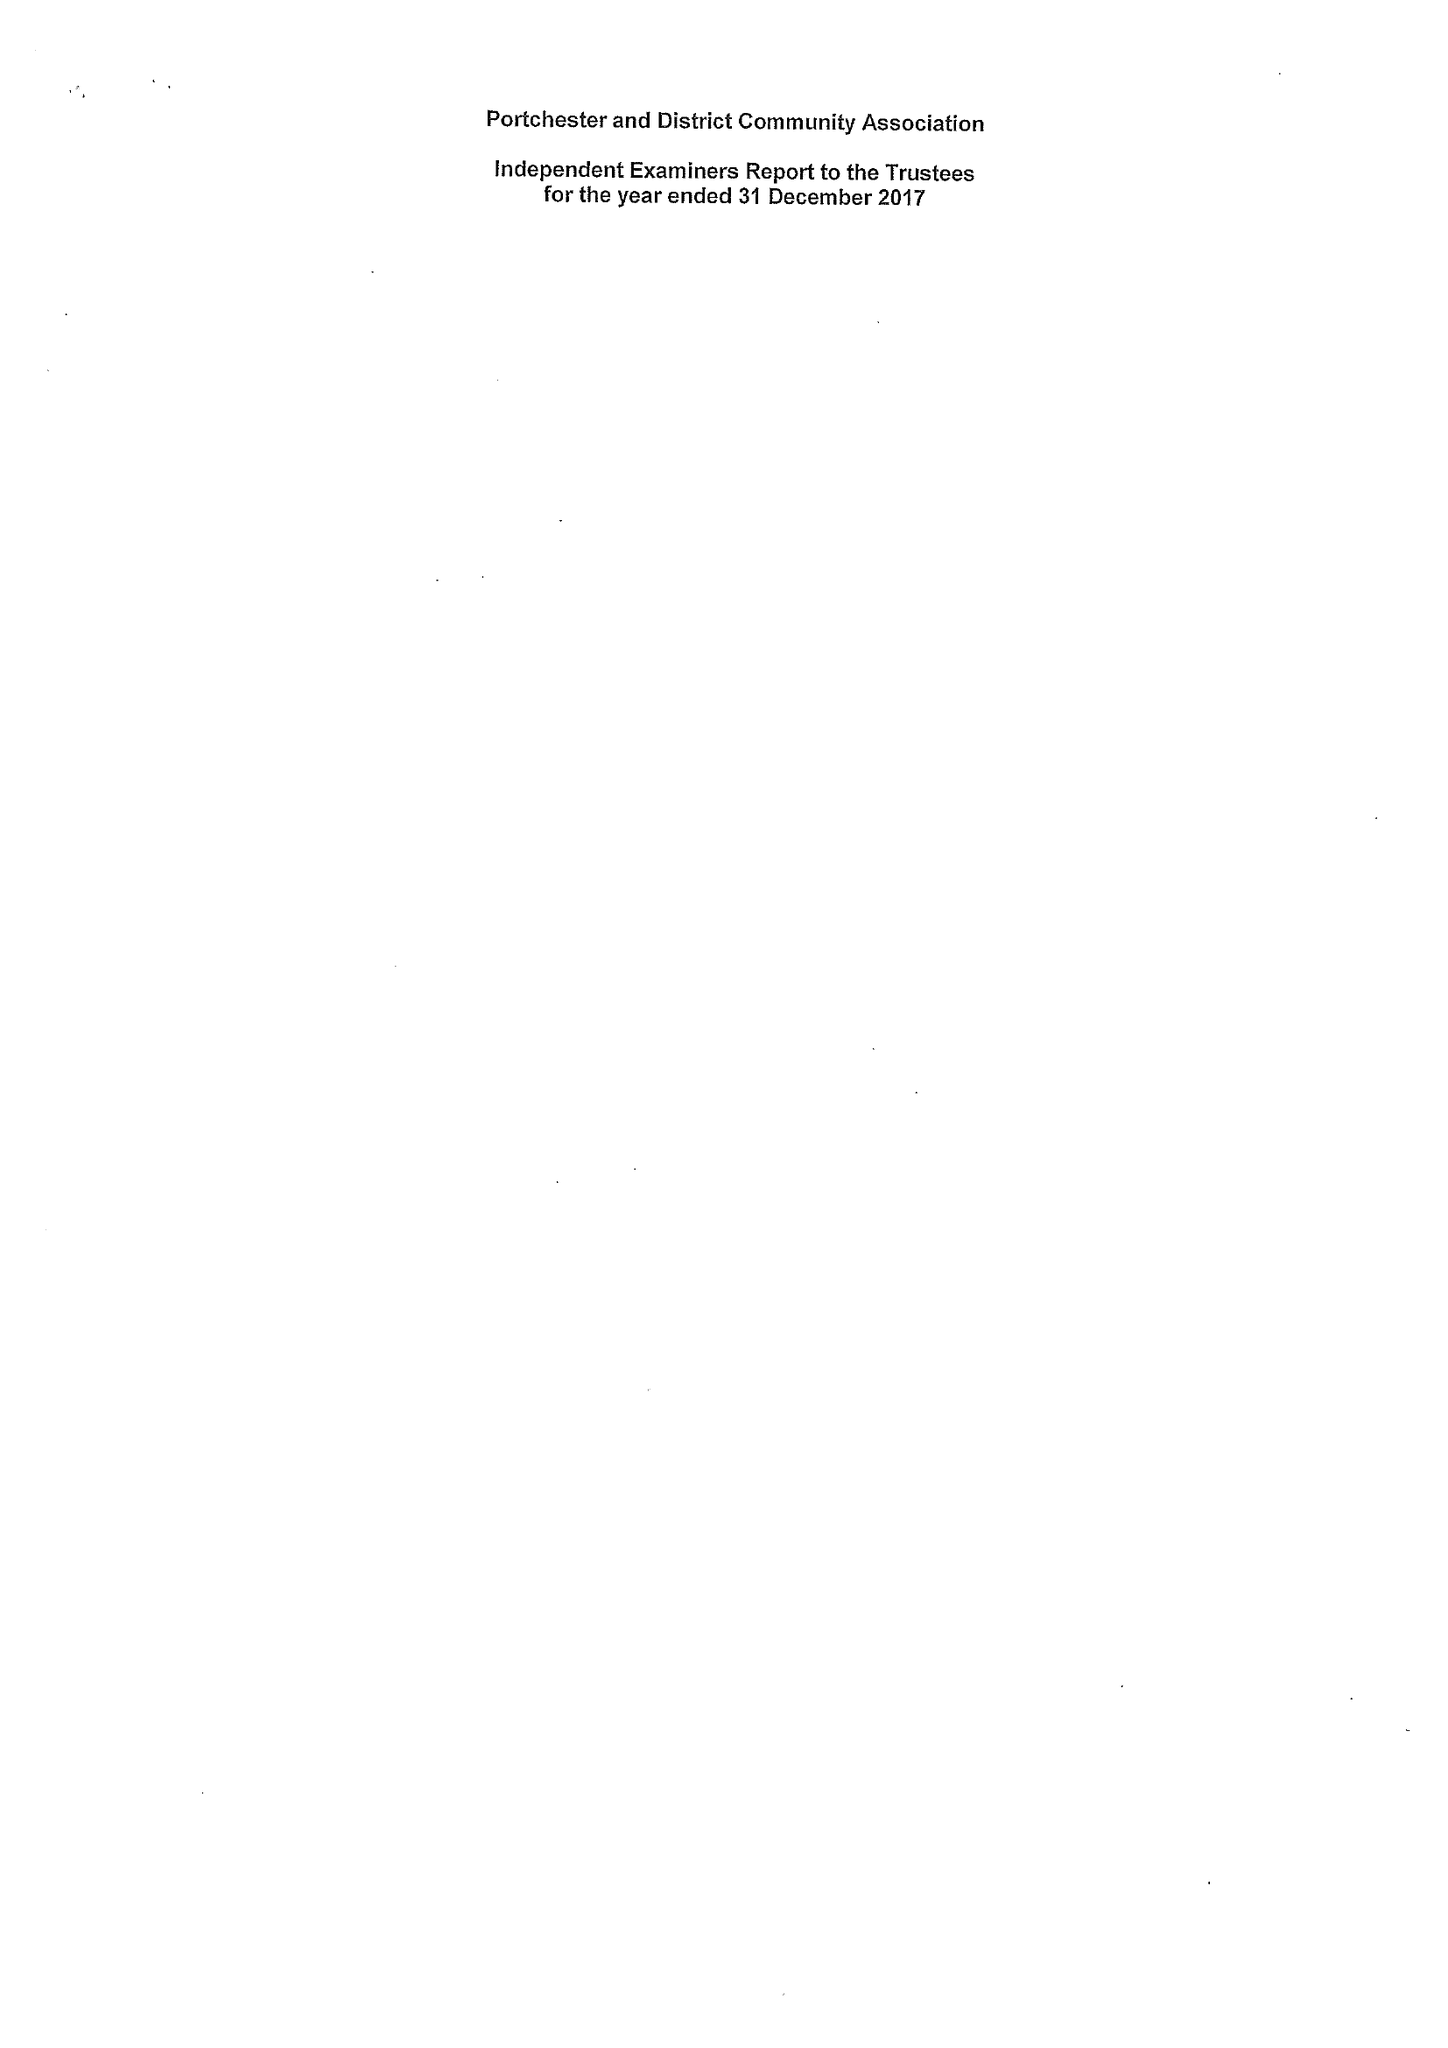What is the value for the charity_number?
Answer the question using a single word or phrase. 1154548 